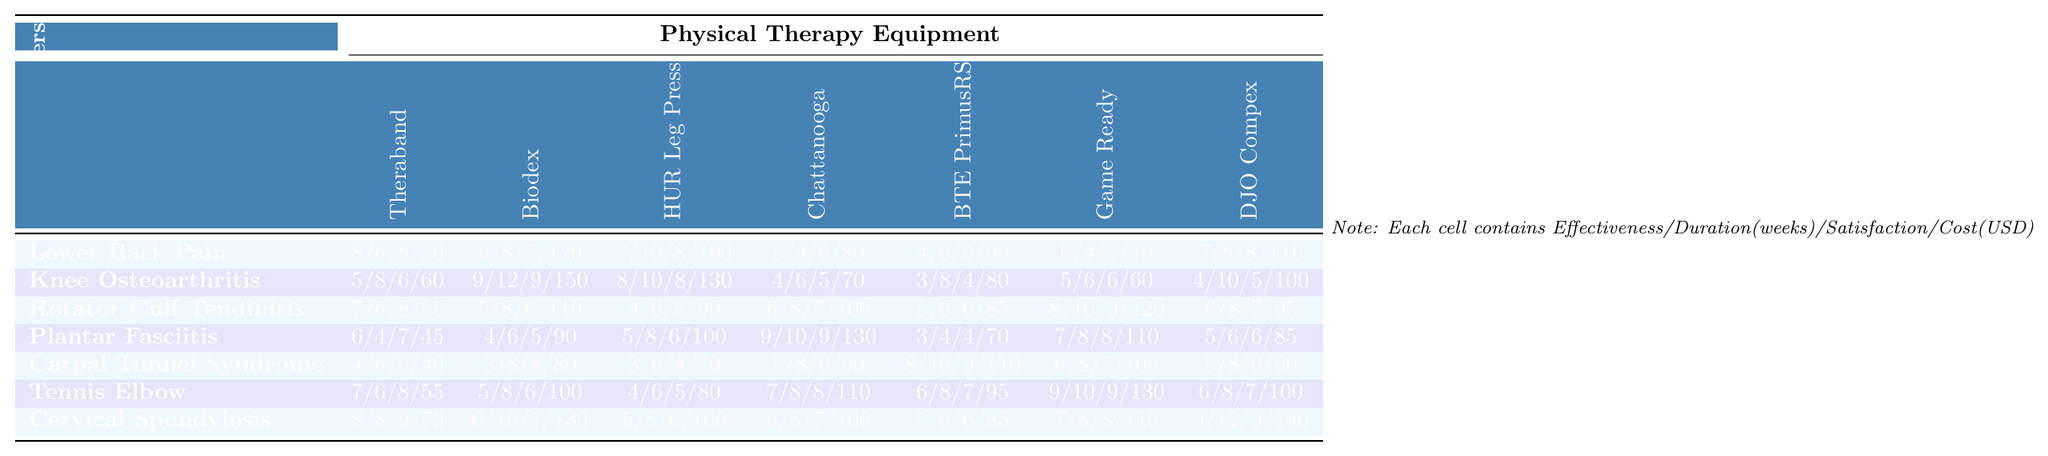What is the effectiveness score for the HUR Leg Press Machine in treating Cervical Spondylosis? Looking at the row for Cervical Spondylosis, the effectiveness score for the HUR Leg Press Machine is listed as 5.
Answer: 5 Which equipment has the highest patient satisfaction score for Knee Osteoarthritis? In the row for Knee Osteoarthritis, the Biodex Isokinetic Dynamometer has the highest patient satisfaction score of 9.
Answer: Biodex Isokinetic Dynamometer What is the average treatment duration in weeks for Plantar Fasciitis with the Game Ready Ice Compression System? The treatment duration for Plantar Fasciitis with the Game Ready Ice Compression System is 8 weeks, so the average is also 8 weeks.
Answer: 8 weeks Is the cost per treatment for Carpal Tunnel Syndrome using the DJO Compex Edge Muscle Stimulator higher than the average cost across all equipment? The cost for the DJO Compex is 90, and the average of the costs for Carpal Tunnel Syndrome is (40 + 80 + 70 + 90 + 110 + 100 + 90) / 7 = 85. Therefore, 90 is higher than 85.
Answer: Yes What is the difference in effectiveness scores between the Biodex Isokinetic Dynamometer for Knee Osteoarthritis and Rotator Cuff Tendinitis? For Knee Osteoarthritis, the effectiveness score for Biodex is 9. For Rotator Cuff Tendinitis, it's 5. The difference is 9 - 5 = 4.
Answer: 4 Which physical therapy equipment has the longest average treatment duration for Lower Back Pain? The maximum treatment duration for Lower Back Pain is 10 weeks with the HUR Leg Press Machine. However, we check all the equipment; the HUR Leg Press Machine has the maximum value, answering the question.
Answer: HUR Leg Press Machine What is the mean effectiveness score for all equipment treating Cervical Spondylosis? The effectiveness scores for Cervical Spondylosis across all equipment are 8, 6, 5, 6, 5, 7, and 9. Adding these scores gives us 46. There are 7 scores, so the mean is 46/7 = 6.57.
Answer: 6.57 How much more effective is the Theraband Resistance Bands for Lower Back Pain compared to Plantar Fasciitis? The effectiveness score for Lower Back Pain with Theraband is 8, and for Plantar Fasciitis, it's 6. The difference is 8 - 6 = 2.
Answer: 2 Is the effectiveness score for the Game Ready Ice Compression System for Tennis Elbow equal to its patient satisfaction score? The effectiveness score for Tennis Elbow is 9, and the patient satisfaction score for Tennis Elbow using Game Ready is also 9. They are equal.
Answer: Yes What is the total cost for treating Knee Osteoarthritis with all pieces of equipment? The costs for treating Knee Osteoarthritis are 60, 150, 130, 70, 80, 60, and 100. Adding these gives 60 + 150 + 130 + 70 + 80 + 60 + 100 = 650.
Answer: 650 